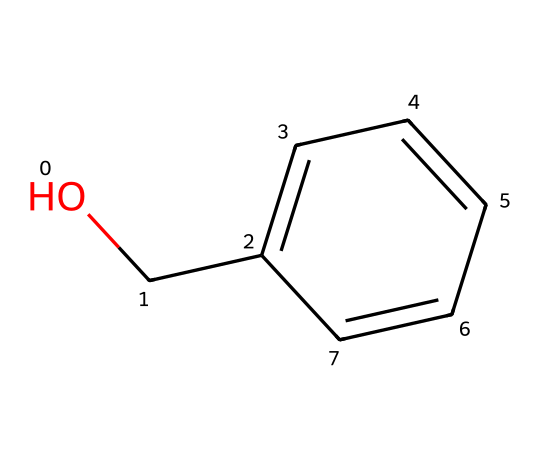What is the molecular formula of benzyl alcohol? The molecular formula can be derived by counting the number of each type of atom in the given structure. The structure shows one oxygen atom, one benzene ring (which has six carbon atoms and five hydrogen atoms), and one additional carbon and hydroxyl group. Therefore, the molecular formula is C7H8O.
Answer: C7H8O How many carbon atoms are in benzyl alcohol? By examining the SMILES representation, we can count the carbon atoms present. There are six carbon atoms from the benzene ring and one additional carbon atom from the hydroxymethyl group, totaling seven carbon atoms.
Answer: 7 Is benzyl alcohol polar or nonpolar? Polarity can be assessed by the presence of polar functional groups. The hydroxyl (-OH) group in benzyl alcohol is polar, making the entire molecule polar despite the nonpolar benzene ring.
Answer: polar What type of functional group is present in benzyl alcohol? The structure shows a hydroxyl (-OH) group attached to the benzene ring, which is characteristic of alcohol functional groups. Therefore, the functional group is hydroxyl.
Answer: hydroxyl Why is benzyl alcohol used as a fixative in perfumes? Benzyl alcohol has properties that allow it to stabilize scents and enhance fragrance longevity. It acts as a fixative by slowing down the evaporation of more volatile aromatic compounds in the perfume.
Answer: fixative How many hydrogen atoms are in benzyl alcohol? From the structure, there are five hydrogen atoms in the benzene ring and three from the hydroxymethyl group (totaling eight), confirming that benzyl alcohol has eight hydrogen atoms.
Answer: 8 